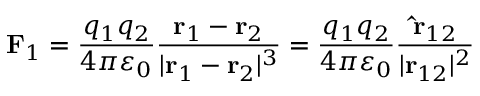<formula> <loc_0><loc_0><loc_500><loc_500>F _ { 1 } = { \frac { q _ { 1 } q _ { 2 } } { 4 \pi \varepsilon _ { 0 } } } { \frac { r _ { 1 } - r _ { 2 } } { | r _ { 1 } - r _ { 2 } | ^ { 3 } } } = { \frac { q _ { 1 } q _ { 2 } } { 4 \pi \varepsilon _ { 0 } } } { \frac { \hat { r } _ { 1 2 } } { | r _ { 1 2 } | ^ { 2 } } }</formula> 